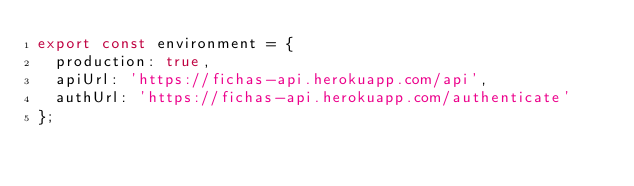<code> <loc_0><loc_0><loc_500><loc_500><_TypeScript_>export const environment = {
  production: true,
  apiUrl: 'https://fichas-api.herokuapp.com/api',
  authUrl: 'https://fichas-api.herokuapp.com/authenticate'
};
</code> 